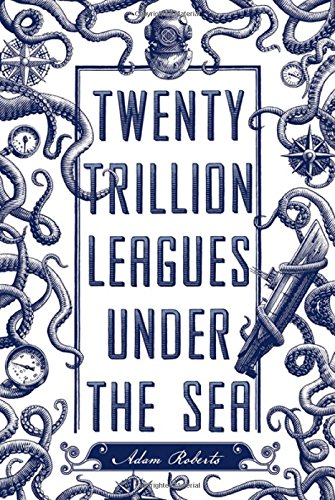How does the cover design reflect the themes of the book? The intricate cover design, teeming with marine life, clockworks, and nautical elements, visually encapsulates themes of deep-sea exploration and the enigmatic passage of time, central to science fiction narratives. What do the tentacles on the cover suggest about the book's content? The tentacles evoke a quintessential image of oceanic mystery and the unknown, perhaps hinting at encounters with extraordinary creatures or the challenges awaiting in the book's depths. 